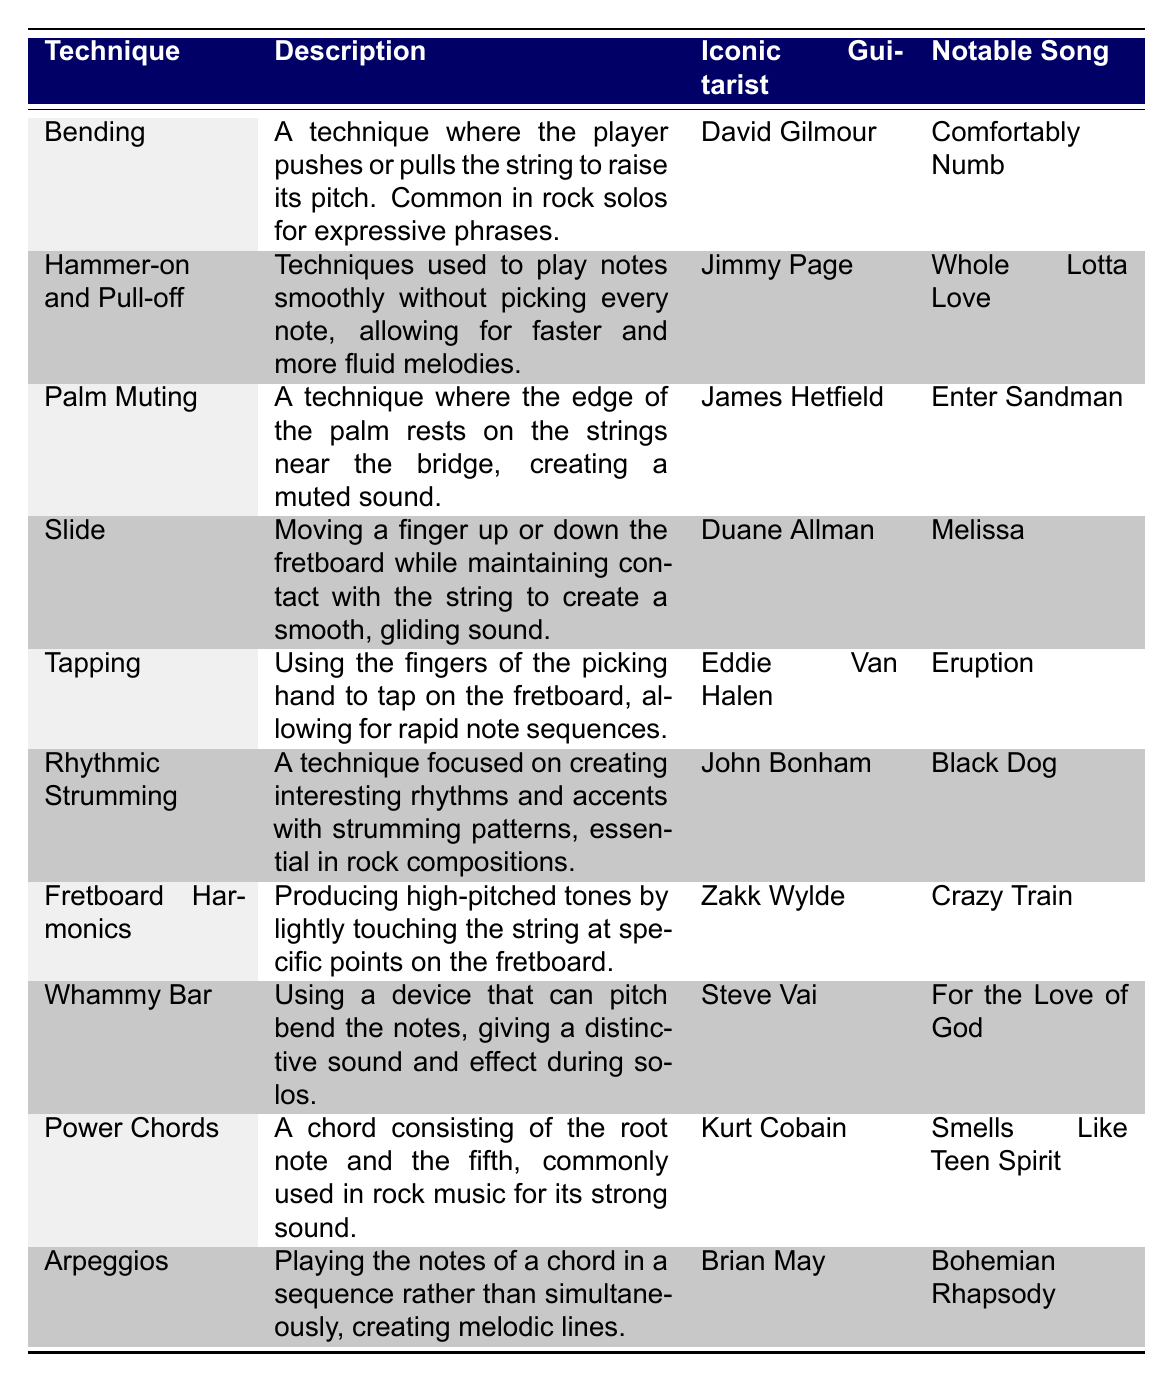What guitar technique is associated with David Gilmour? The table indicates that David Gilmour is associated with the technique "Bending." This is directly mentioned in the row corresponding to Gilmour.
Answer: Bending Which guitarist is known for using "Palm Muting"? The table shows that James Hetfield is the guitarist known for the technique "Palm Muting." It is clearly listed next to his name in the table.
Answer: James Hetfield Is "Tapping" used by John Bonham in his notable song? Referring to the table, "Tapping" is associated with Eddie Van Halen, not John Bonham. Therefore, the fact is false.
Answer: No How many guitarists are noted for using the technique "Slide"? From the table, only one entry corresponds to "Slide," which is attributed to Duane Allman. Therefore, there is just one guitarist noted for this technique.
Answer: 1 Which technique comprises the use of a guitar device that can pitch bend notes? The table indicates that the "Whammy Bar" technique involves the use of a guitar device for pitch bending. This can be easily identified in the corresponding row.
Answer: Whammy Bar Who played "Whole Lotta Love" utilizing "Hammer-on and Pull-off"? The table specifies that Jimmy Page is the iconic guitarist known for using "Hammer-on and Pull-off" in the song "Whole Lotta Love," as stated clearly in his row.
Answer: Jimmy Page What is the notable song associated with the "Fretboard Harmonics" technique? By looking at the table, we see that the notable song associated with "Fretboard Harmonics" is "Crazy Train," linked to Zakk Wylde. We can simply refer to the entry under this technique.
Answer: Crazy Train Which iconic guitarist is associated with the use of "Power Chords"? According to the table, "Power Chords" is associated with Kurt Cobain. This information is stated in his corresponding column, providing a direct answer.
Answer: Kurt Cobain What techniques are associated with rock music for faster melodies, and who is the guitarist? "Hammer-on and Pull-off" are the techniques used for smoother, faster melodies, as mentioned in the table. This technique is associated with guitarist Jimmy Page.
Answer: Hammer-on and Pull-off, Jimmy Page 